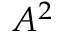Convert formula to latex. <formula><loc_0><loc_0><loc_500><loc_500>A ^ { 2 }</formula> 